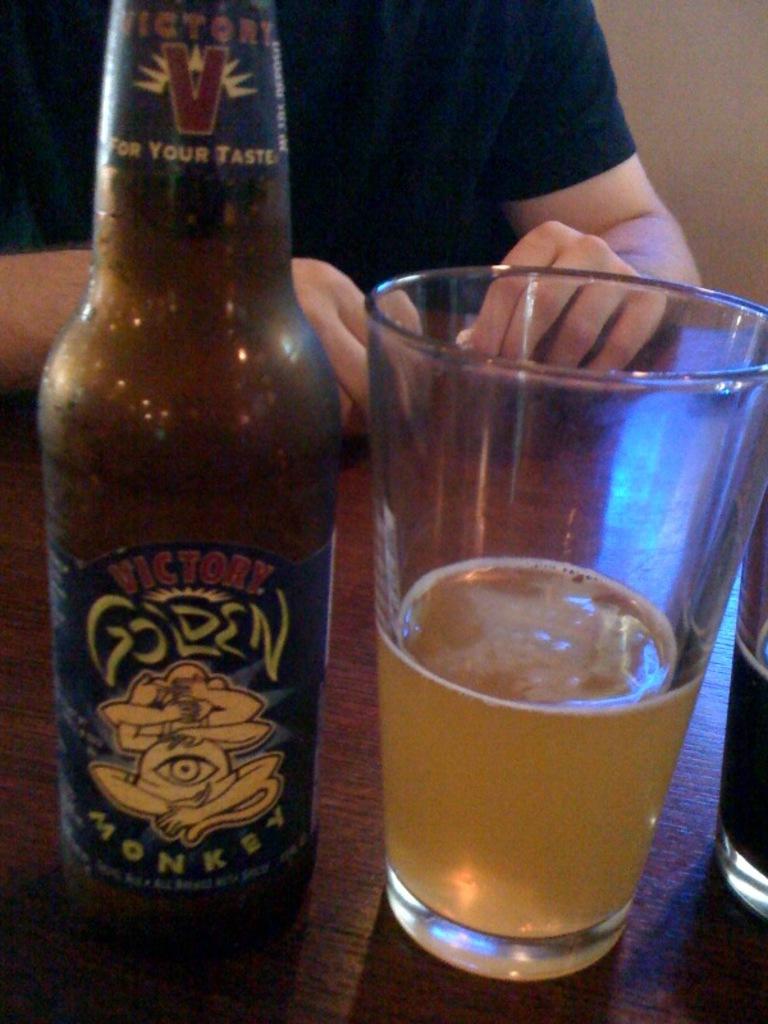What is the name of the beer?
Provide a short and direct response. Golden monkey. 